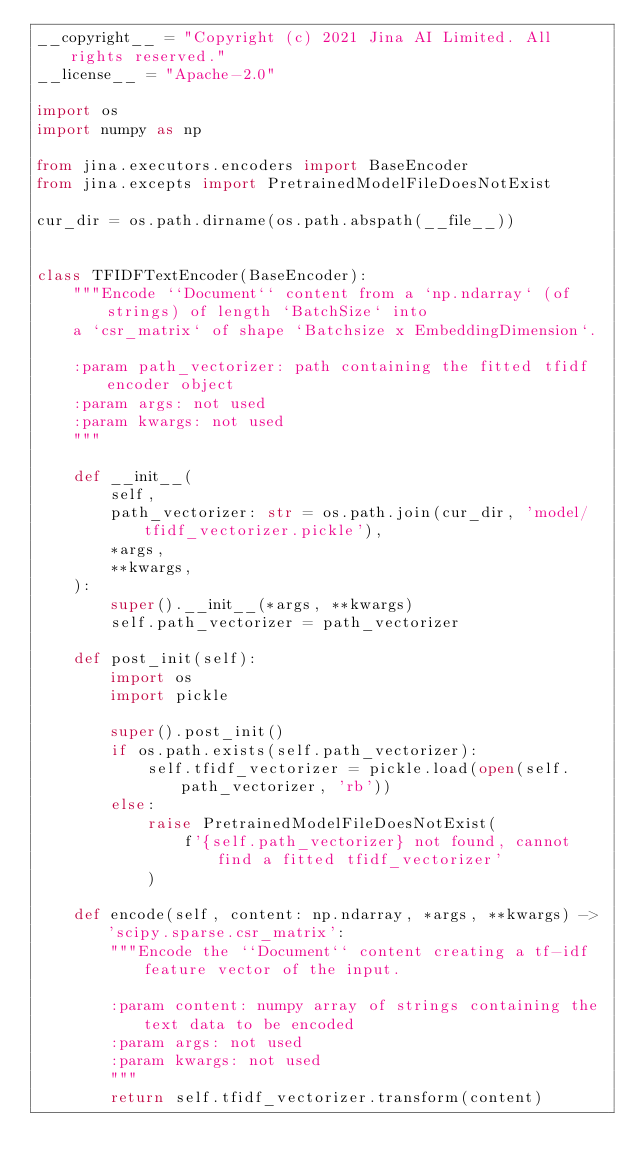<code> <loc_0><loc_0><loc_500><loc_500><_Python_>__copyright__ = "Copyright (c) 2021 Jina AI Limited. All rights reserved."
__license__ = "Apache-2.0"

import os
import numpy as np

from jina.executors.encoders import BaseEncoder
from jina.excepts import PretrainedModelFileDoesNotExist

cur_dir = os.path.dirname(os.path.abspath(__file__))


class TFIDFTextEncoder(BaseEncoder):
    """Encode ``Document`` content from a `np.ndarray` (of strings) of length `BatchSize` into
    a `csr_matrix` of shape `Batchsize x EmbeddingDimension`.

    :param path_vectorizer: path containing the fitted tfidf encoder object
    :param args: not used
    :param kwargs: not used
    """

    def __init__(
        self,
        path_vectorizer: str = os.path.join(cur_dir, 'model/tfidf_vectorizer.pickle'),
        *args,
        **kwargs,
    ):
        super().__init__(*args, **kwargs)
        self.path_vectorizer = path_vectorizer

    def post_init(self):
        import os
        import pickle

        super().post_init()
        if os.path.exists(self.path_vectorizer):
            self.tfidf_vectorizer = pickle.load(open(self.path_vectorizer, 'rb'))
        else:
            raise PretrainedModelFileDoesNotExist(
                f'{self.path_vectorizer} not found, cannot find a fitted tfidf_vectorizer'
            )

    def encode(self, content: np.ndarray, *args, **kwargs) -> 'scipy.sparse.csr_matrix':
        """Encode the ``Document`` content creating a tf-idf feature vector of the input.

        :param content: numpy array of strings containing the text data to be encoded
        :param args: not used
        :param kwargs: not used
        """
        return self.tfidf_vectorizer.transform(content)
</code> 